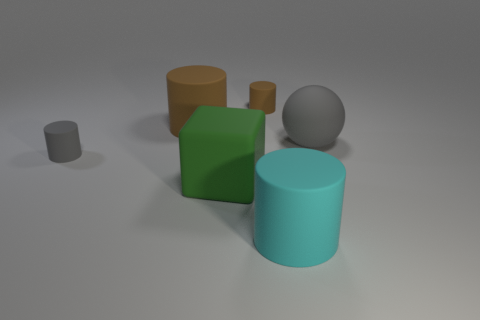How many brown cylinders must be subtracted to get 1 brown cylinders? 1 Subtract all blue spheres. Subtract all brown cylinders. How many spheres are left? 1 Add 3 big green cubes. How many objects exist? 9 Subtract all cubes. How many objects are left? 5 Add 2 gray rubber things. How many gray rubber things exist? 4 Subtract 0 brown spheres. How many objects are left? 6 Subtract all big blue metallic things. Subtract all large cyan cylinders. How many objects are left? 5 Add 4 large cyan rubber things. How many large cyan rubber things are left? 5 